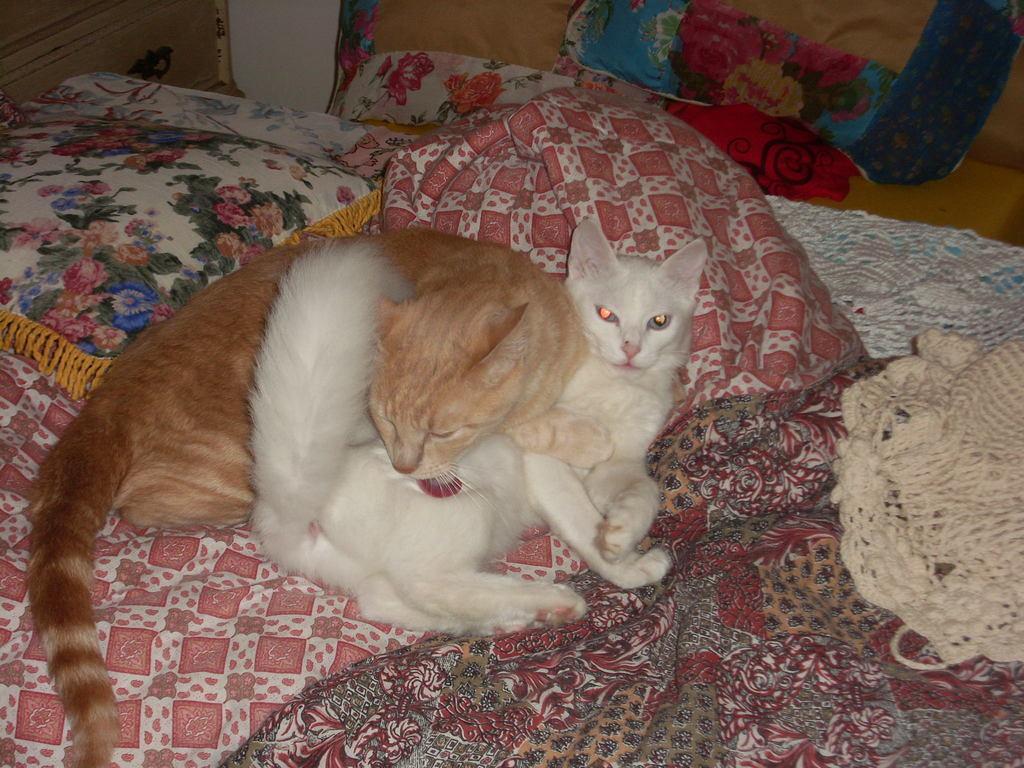Please provide a concise description of this image. In this picture we can see two cats sitting on the bed. We can see a brown cat lying on the white cat. There are a few blankets and a woolen cloth on the bed on the right side. There are some clothes and a cupboard in the background. 